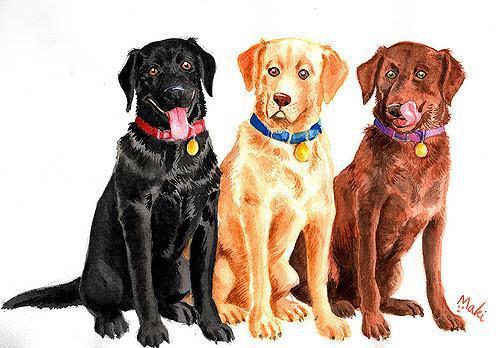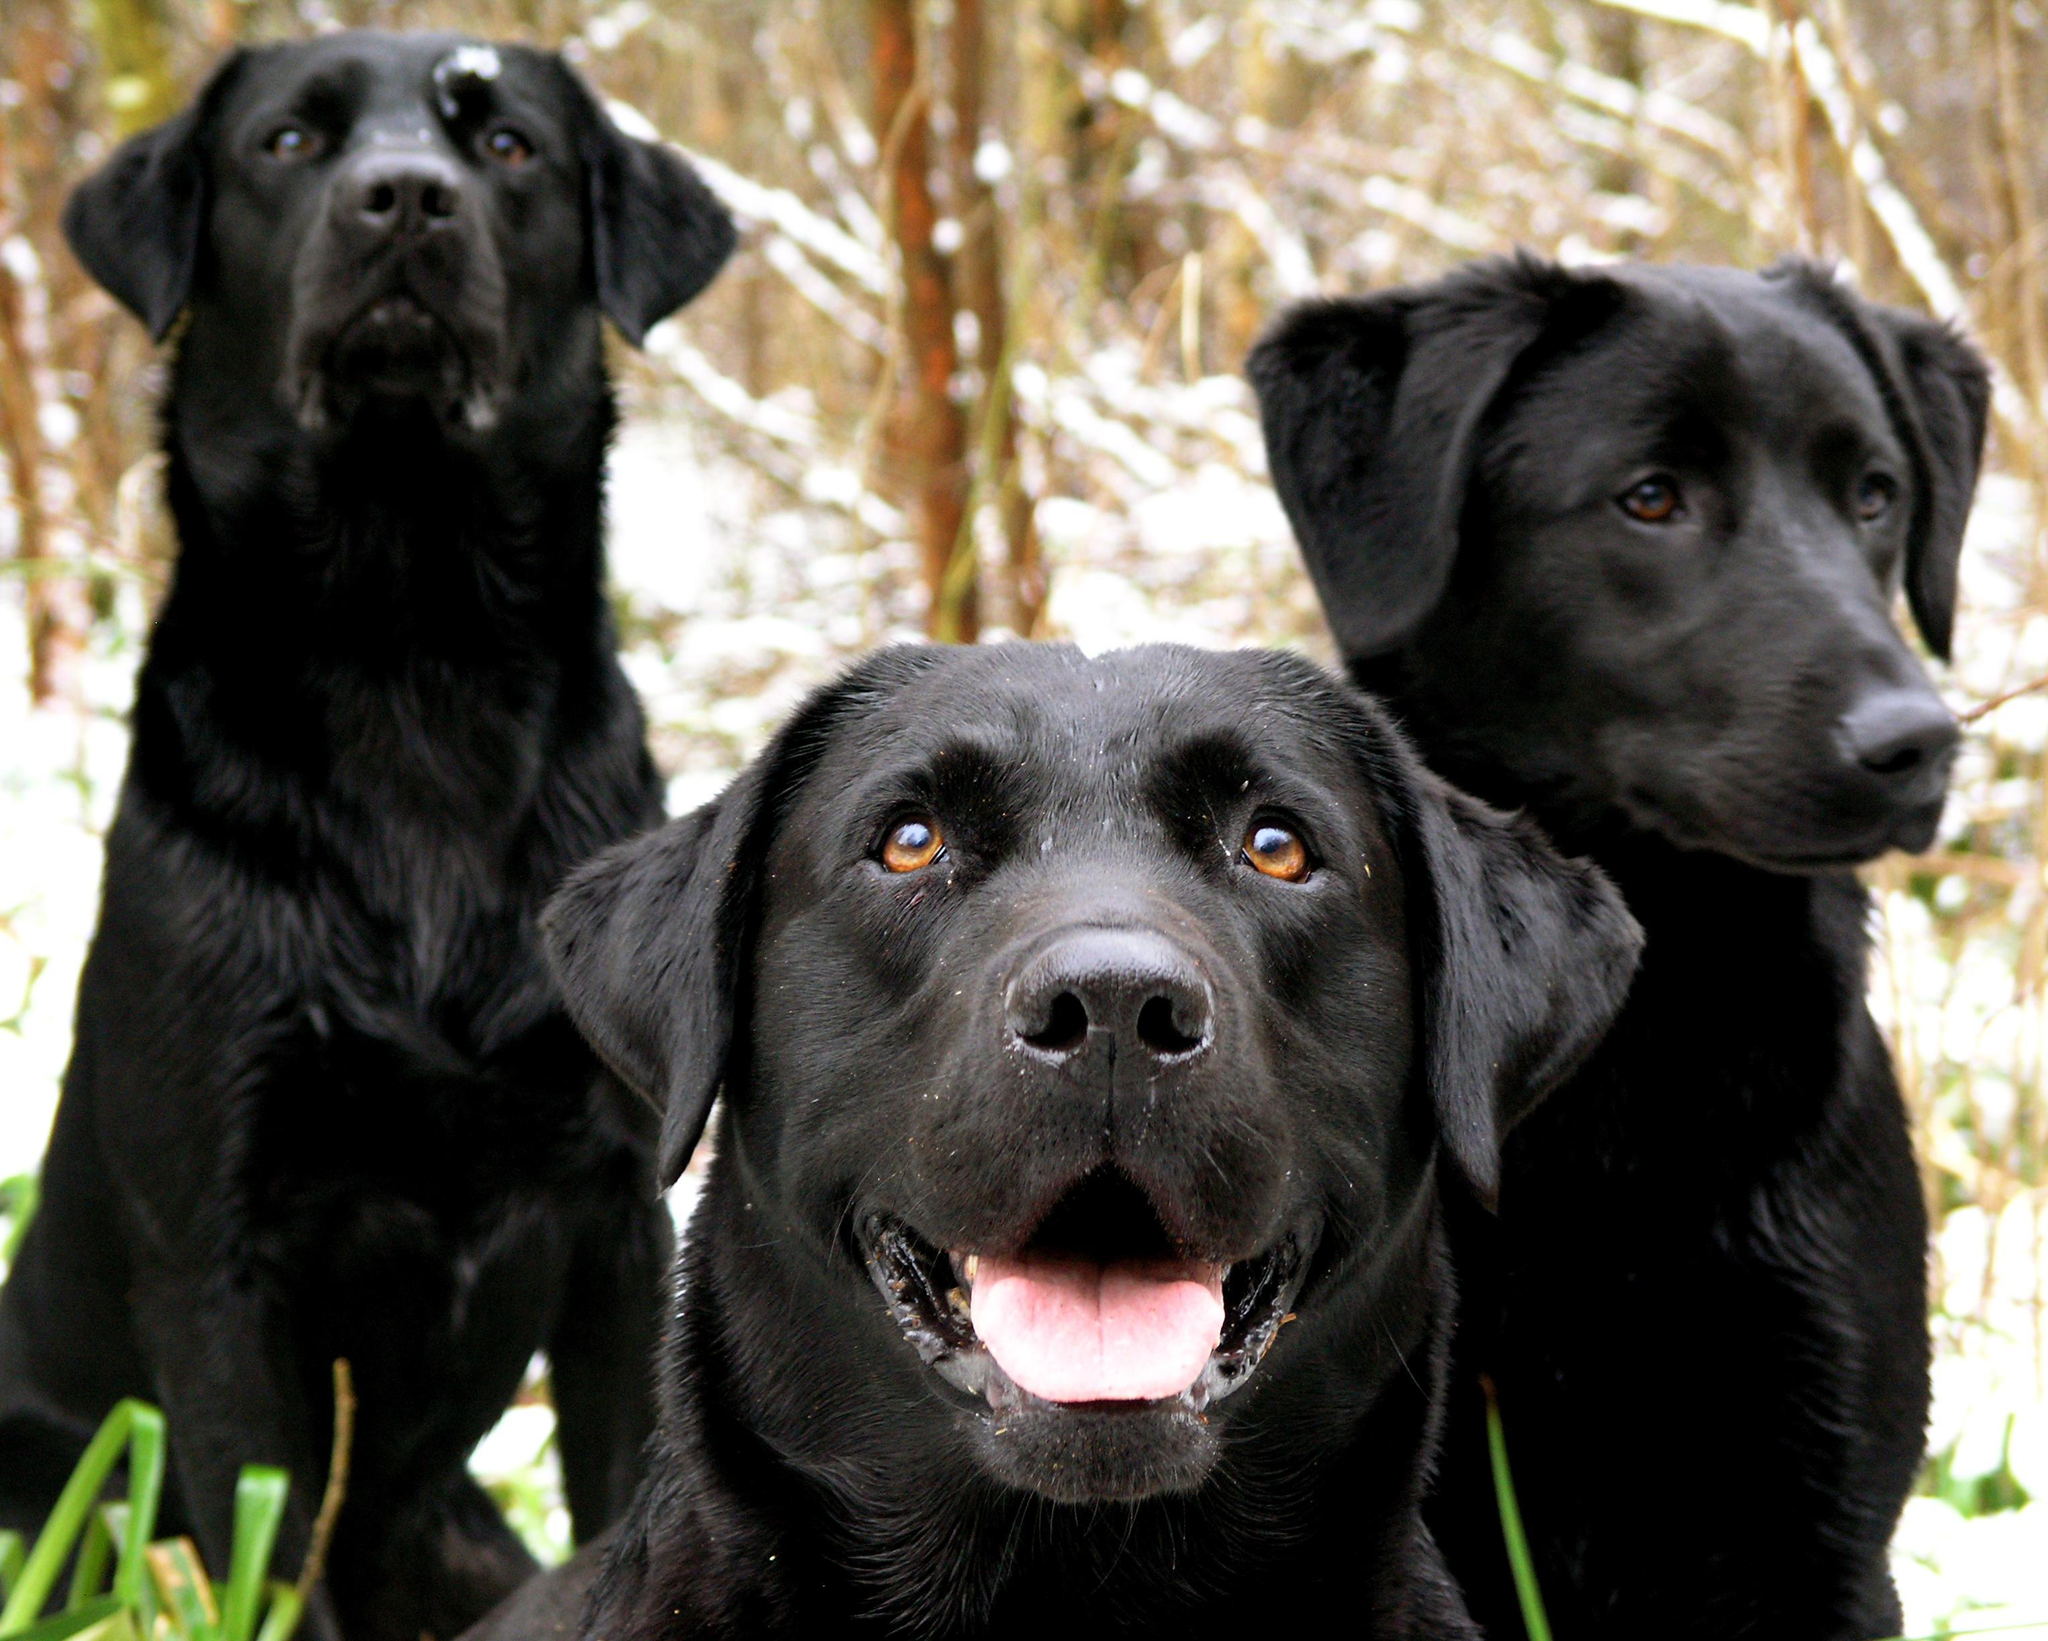The first image is the image on the left, the second image is the image on the right. Assess this claim about the two images: "There is a total of six dogs.". Correct or not? Answer yes or no. Yes. 